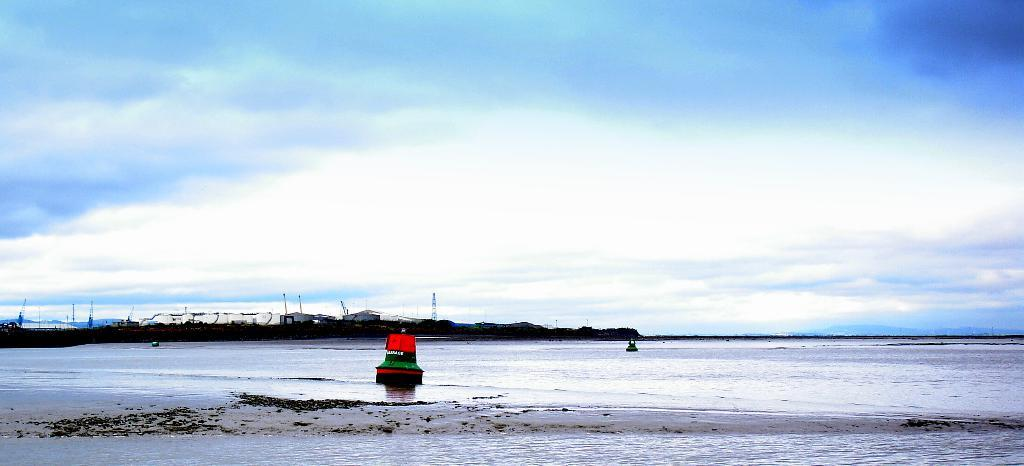What type of body of water is present in the image? There is an ocean in the image. What objects can be seen floating on the water? There are two boats floating on the water in the image. What can be seen in the sky in the background of the image? There are clouds visible in the sky in the background of the image. What type of shoe can be seen floating in the ocean in the image? There is no shoe visible in the image; it only features an ocean and two boats. 